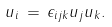<formula> <loc_0><loc_0><loc_500><loc_500>u _ { i } \, = \, \epsilon _ { i j k } u _ { j } u _ { k } .</formula> 